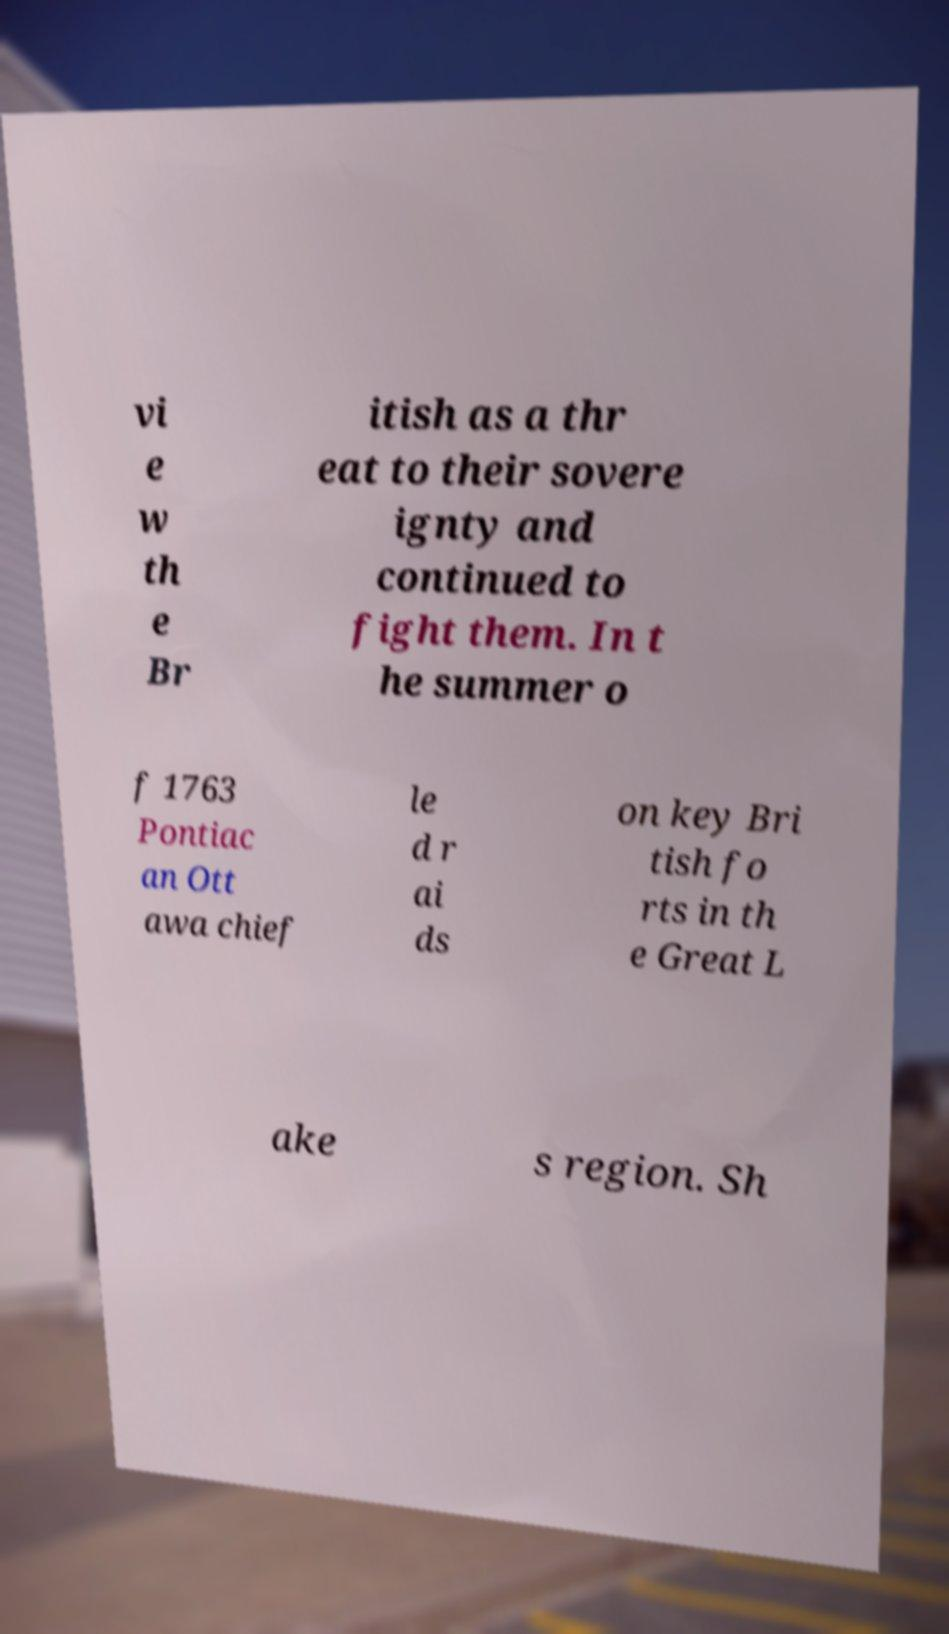Could you extract and type out the text from this image? vi e w th e Br itish as a thr eat to their sovere ignty and continued to fight them. In t he summer o f 1763 Pontiac an Ott awa chief le d r ai ds on key Bri tish fo rts in th e Great L ake s region. Sh 